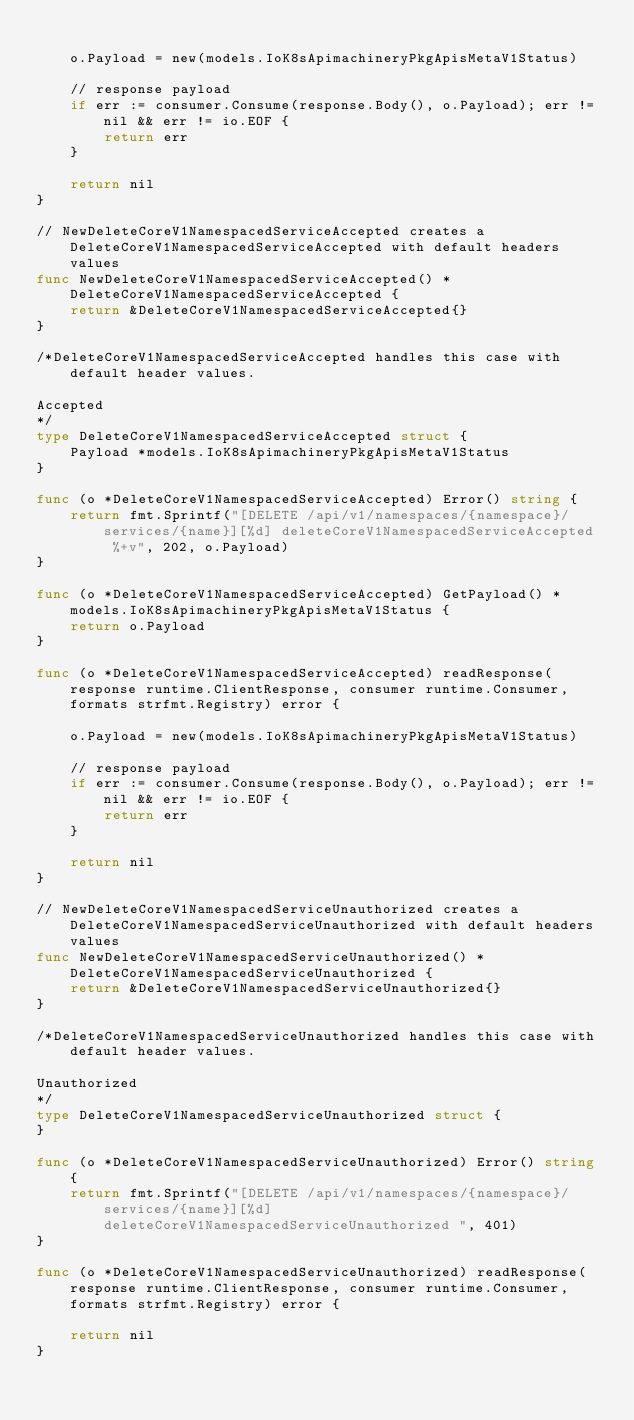Convert code to text. <code><loc_0><loc_0><loc_500><loc_500><_Go_>
	o.Payload = new(models.IoK8sApimachineryPkgApisMetaV1Status)

	// response payload
	if err := consumer.Consume(response.Body(), o.Payload); err != nil && err != io.EOF {
		return err
	}

	return nil
}

// NewDeleteCoreV1NamespacedServiceAccepted creates a DeleteCoreV1NamespacedServiceAccepted with default headers values
func NewDeleteCoreV1NamespacedServiceAccepted() *DeleteCoreV1NamespacedServiceAccepted {
	return &DeleteCoreV1NamespacedServiceAccepted{}
}

/*DeleteCoreV1NamespacedServiceAccepted handles this case with default header values.

Accepted
*/
type DeleteCoreV1NamespacedServiceAccepted struct {
	Payload *models.IoK8sApimachineryPkgApisMetaV1Status
}

func (o *DeleteCoreV1NamespacedServiceAccepted) Error() string {
	return fmt.Sprintf("[DELETE /api/v1/namespaces/{namespace}/services/{name}][%d] deleteCoreV1NamespacedServiceAccepted  %+v", 202, o.Payload)
}

func (o *DeleteCoreV1NamespacedServiceAccepted) GetPayload() *models.IoK8sApimachineryPkgApisMetaV1Status {
	return o.Payload
}

func (o *DeleteCoreV1NamespacedServiceAccepted) readResponse(response runtime.ClientResponse, consumer runtime.Consumer, formats strfmt.Registry) error {

	o.Payload = new(models.IoK8sApimachineryPkgApisMetaV1Status)

	// response payload
	if err := consumer.Consume(response.Body(), o.Payload); err != nil && err != io.EOF {
		return err
	}

	return nil
}

// NewDeleteCoreV1NamespacedServiceUnauthorized creates a DeleteCoreV1NamespacedServiceUnauthorized with default headers values
func NewDeleteCoreV1NamespacedServiceUnauthorized() *DeleteCoreV1NamespacedServiceUnauthorized {
	return &DeleteCoreV1NamespacedServiceUnauthorized{}
}

/*DeleteCoreV1NamespacedServiceUnauthorized handles this case with default header values.

Unauthorized
*/
type DeleteCoreV1NamespacedServiceUnauthorized struct {
}

func (o *DeleteCoreV1NamespacedServiceUnauthorized) Error() string {
	return fmt.Sprintf("[DELETE /api/v1/namespaces/{namespace}/services/{name}][%d] deleteCoreV1NamespacedServiceUnauthorized ", 401)
}

func (o *DeleteCoreV1NamespacedServiceUnauthorized) readResponse(response runtime.ClientResponse, consumer runtime.Consumer, formats strfmt.Registry) error {

	return nil
}
</code> 